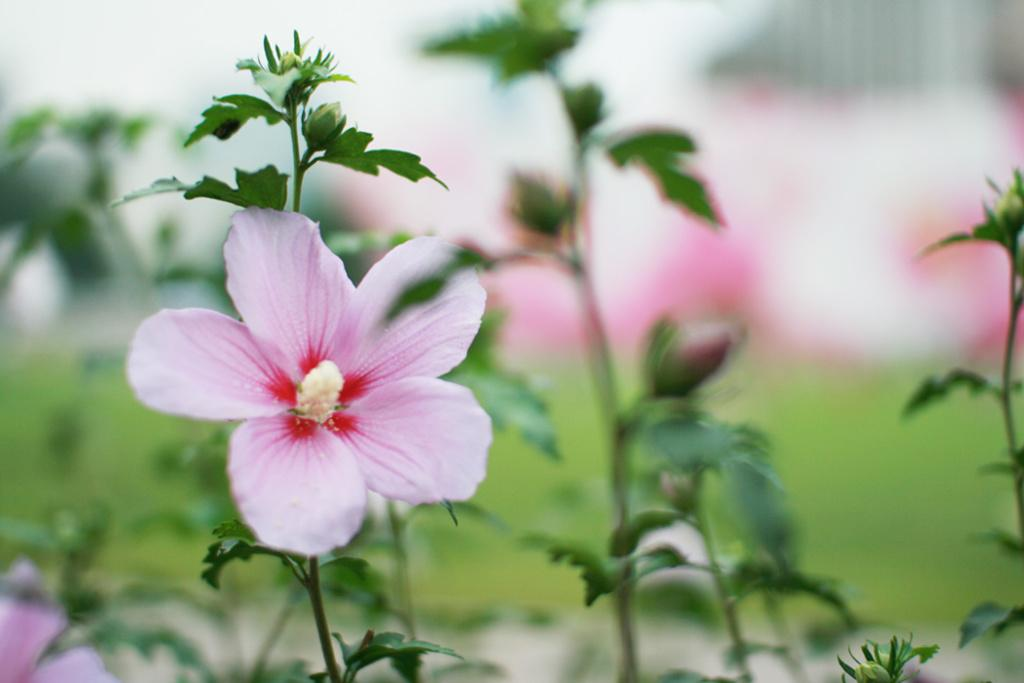What type of living organisms can be seen in the image? Plants and flowers are visible in the image. Can you describe the flowers in the image? The flowers in the image are part of the plants and add color and beauty to the scene. What type of drum can be seen in the image? There is no drum present in the image; it features plants and flowers. How is the quill used in the image? There is no quill present in the image; it only contains plants and flowers. 